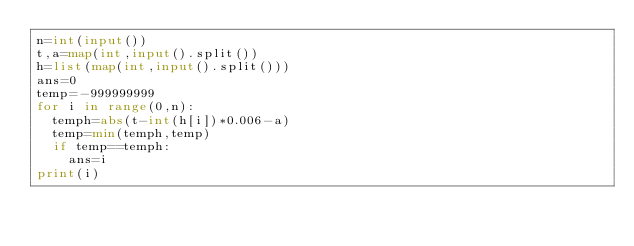<code> <loc_0><loc_0><loc_500><loc_500><_Python_>n=int(input())
t,a=map(int,input().split())
h=list(map(int,input().split()))
ans=0
temp=-999999999
for i in range(0,n):
  temph=abs(t-int(h[i])*0.006-a)
  temp=min(temph,temp)
  if temp==temph:
    ans=i
print(i)</code> 